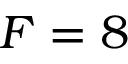Convert formula to latex. <formula><loc_0><loc_0><loc_500><loc_500>F = 8</formula> 